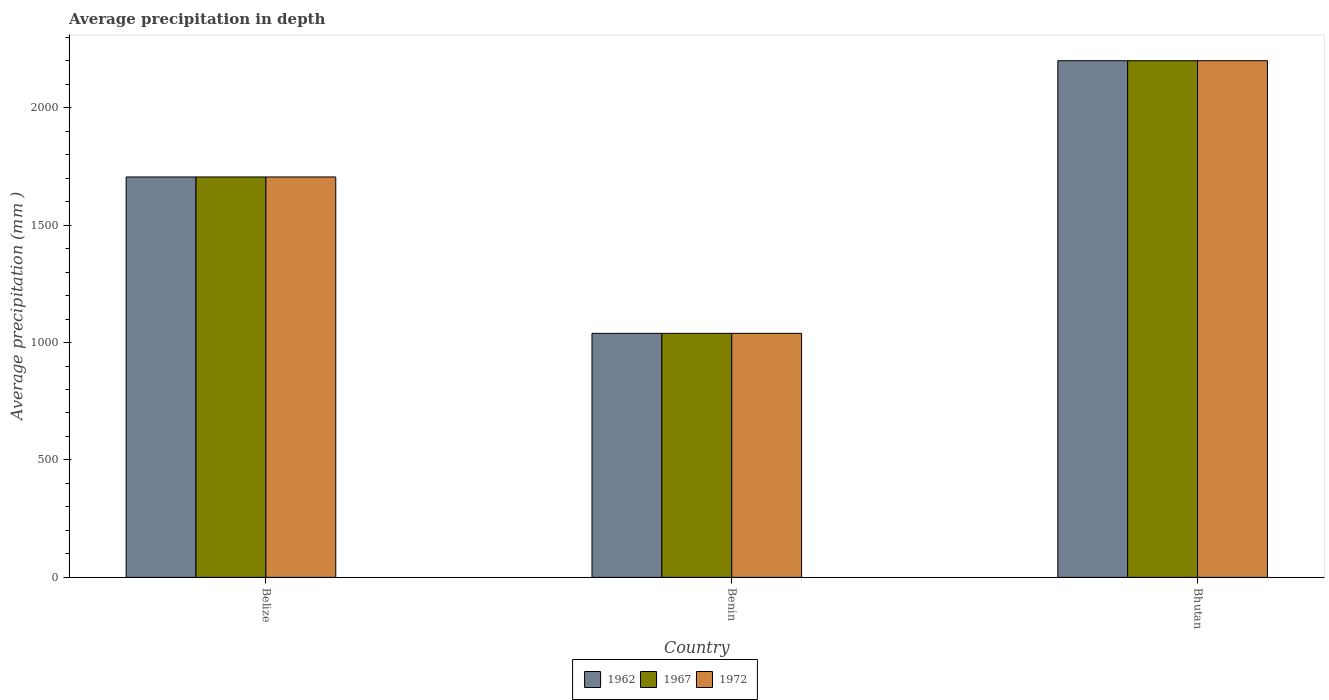Are the number of bars per tick equal to the number of legend labels?
Your answer should be compact. Yes. Are the number of bars on each tick of the X-axis equal?
Give a very brief answer. Yes. How many bars are there on the 2nd tick from the right?
Keep it short and to the point. 3. What is the label of the 3rd group of bars from the left?
Your answer should be very brief. Bhutan. What is the average precipitation in 1972 in Belize?
Offer a very short reply. 1705. Across all countries, what is the maximum average precipitation in 1962?
Ensure brevity in your answer.  2200. Across all countries, what is the minimum average precipitation in 1962?
Provide a short and direct response. 1039. In which country was the average precipitation in 1967 maximum?
Offer a terse response. Bhutan. In which country was the average precipitation in 1962 minimum?
Offer a terse response. Benin. What is the total average precipitation in 1962 in the graph?
Your response must be concise. 4944. What is the difference between the average precipitation in 1962 in Belize and that in Benin?
Ensure brevity in your answer.  666. What is the difference between the average precipitation in 1962 in Benin and the average precipitation in 1967 in Bhutan?
Your answer should be very brief. -1161. What is the average average precipitation in 1967 per country?
Keep it short and to the point. 1648. What is the ratio of the average precipitation in 1962 in Benin to that in Bhutan?
Offer a terse response. 0.47. Is the average precipitation in 1962 in Belize less than that in Bhutan?
Your answer should be compact. Yes. Is the difference between the average precipitation in 1972 in Belize and Bhutan greater than the difference between the average precipitation in 1967 in Belize and Bhutan?
Your answer should be very brief. No. What is the difference between the highest and the second highest average precipitation in 1972?
Ensure brevity in your answer.  495. What is the difference between the highest and the lowest average precipitation in 1962?
Ensure brevity in your answer.  1161. Is the sum of the average precipitation in 1972 in Belize and Bhutan greater than the maximum average precipitation in 1967 across all countries?
Your answer should be compact. Yes. Are all the bars in the graph horizontal?
Provide a succinct answer. No. How many countries are there in the graph?
Give a very brief answer. 3. Does the graph contain any zero values?
Your response must be concise. No. Does the graph contain grids?
Provide a succinct answer. No. How are the legend labels stacked?
Provide a succinct answer. Horizontal. What is the title of the graph?
Give a very brief answer. Average precipitation in depth. Does "1961" appear as one of the legend labels in the graph?
Ensure brevity in your answer.  No. What is the label or title of the X-axis?
Make the answer very short. Country. What is the label or title of the Y-axis?
Provide a short and direct response. Average precipitation (mm ). What is the Average precipitation (mm ) of 1962 in Belize?
Ensure brevity in your answer.  1705. What is the Average precipitation (mm ) in 1967 in Belize?
Offer a very short reply. 1705. What is the Average precipitation (mm ) of 1972 in Belize?
Your answer should be very brief. 1705. What is the Average precipitation (mm ) in 1962 in Benin?
Offer a terse response. 1039. What is the Average precipitation (mm ) of 1967 in Benin?
Make the answer very short. 1039. What is the Average precipitation (mm ) of 1972 in Benin?
Ensure brevity in your answer.  1039. What is the Average precipitation (mm ) of 1962 in Bhutan?
Ensure brevity in your answer.  2200. What is the Average precipitation (mm ) in 1967 in Bhutan?
Your answer should be very brief. 2200. What is the Average precipitation (mm ) of 1972 in Bhutan?
Keep it short and to the point. 2200. Across all countries, what is the maximum Average precipitation (mm ) of 1962?
Offer a very short reply. 2200. Across all countries, what is the maximum Average precipitation (mm ) of 1967?
Your response must be concise. 2200. Across all countries, what is the maximum Average precipitation (mm ) in 1972?
Make the answer very short. 2200. Across all countries, what is the minimum Average precipitation (mm ) in 1962?
Your response must be concise. 1039. Across all countries, what is the minimum Average precipitation (mm ) in 1967?
Make the answer very short. 1039. Across all countries, what is the minimum Average precipitation (mm ) in 1972?
Keep it short and to the point. 1039. What is the total Average precipitation (mm ) of 1962 in the graph?
Give a very brief answer. 4944. What is the total Average precipitation (mm ) of 1967 in the graph?
Your answer should be compact. 4944. What is the total Average precipitation (mm ) in 1972 in the graph?
Your answer should be very brief. 4944. What is the difference between the Average precipitation (mm ) in 1962 in Belize and that in Benin?
Offer a very short reply. 666. What is the difference between the Average precipitation (mm ) in 1967 in Belize and that in Benin?
Offer a terse response. 666. What is the difference between the Average precipitation (mm ) in 1972 in Belize and that in Benin?
Ensure brevity in your answer.  666. What is the difference between the Average precipitation (mm ) in 1962 in Belize and that in Bhutan?
Your answer should be very brief. -495. What is the difference between the Average precipitation (mm ) of 1967 in Belize and that in Bhutan?
Your answer should be compact. -495. What is the difference between the Average precipitation (mm ) in 1972 in Belize and that in Bhutan?
Make the answer very short. -495. What is the difference between the Average precipitation (mm ) of 1962 in Benin and that in Bhutan?
Your answer should be very brief. -1161. What is the difference between the Average precipitation (mm ) of 1967 in Benin and that in Bhutan?
Offer a very short reply. -1161. What is the difference between the Average precipitation (mm ) in 1972 in Benin and that in Bhutan?
Your answer should be very brief. -1161. What is the difference between the Average precipitation (mm ) of 1962 in Belize and the Average precipitation (mm ) of 1967 in Benin?
Your response must be concise. 666. What is the difference between the Average precipitation (mm ) of 1962 in Belize and the Average precipitation (mm ) of 1972 in Benin?
Offer a very short reply. 666. What is the difference between the Average precipitation (mm ) in 1967 in Belize and the Average precipitation (mm ) in 1972 in Benin?
Your answer should be very brief. 666. What is the difference between the Average precipitation (mm ) in 1962 in Belize and the Average precipitation (mm ) in 1967 in Bhutan?
Your answer should be very brief. -495. What is the difference between the Average precipitation (mm ) in 1962 in Belize and the Average precipitation (mm ) in 1972 in Bhutan?
Provide a short and direct response. -495. What is the difference between the Average precipitation (mm ) in 1967 in Belize and the Average precipitation (mm ) in 1972 in Bhutan?
Ensure brevity in your answer.  -495. What is the difference between the Average precipitation (mm ) in 1962 in Benin and the Average precipitation (mm ) in 1967 in Bhutan?
Your answer should be compact. -1161. What is the difference between the Average precipitation (mm ) of 1962 in Benin and the Average precipitation (mm ) of 1972 in Bhutan?
Provide a succinct answer. -1161. What is the difference between the Average precipitation (mm ) of 1967 in Benin and the Average precipitation (mm ) of 1972 in Bhutan?
Provide a succinct answer. -1161. What is the average Average precipitation (mm ) in 1962 per country?
Offer a very short reply. 1648. What is the average Average precipitation (mm ) in 1967 per country?
Offer a very short reply. 1648. What is the average Average precipitation (mm ) of 1972 per country?
Ensure brevity in your answer.  1648. What is the difference between the Average precipitation (mm ) in 1962 and Average precipitation (mm ) in 1967 in Belize?
Ensure brevity in your answer.  0. What is the difference between the Average precipitation (mm ) in 1962 and Average precipitation (mm ) in 1972 in Belize?
Offer a terse response. 0. What is the difference between the Average precipitation (mm ) of 1962 and Average precipitation (mm ) of 1967 in Benin?
Make the answer very short. 0. What is the difference between the Average precipitation (mm ) in 1962 and Average precipitation (mm ) in 1972 in Benin?
Keep it short and to the point. 0. What is the difference between the Average precipitation (mm ) in 1967 and Average precipitation (mm ) in 1972 in Benin?
Keep it short and to the point. 0. What is the difference between the Average precipitation (mm ) of 1962 and Average precipitation (mm ) of 1967 in Bhutan?
Provide a succinct answer. 0. What is the difference between the Average precipitation (mm ) in 1967 and Average precipitation (mm ) in 1972 in Bhutan?
Keep it short and to the point. 0. What is the ratio of the Average precipitation (mm ) of 1962 in Belize to that in Benin?
Your answer should be compact. 1.64. What is the ratio of the Average precipitation (mm ) of 1967 in Belize to that in Benin?
Make the answer very short. 1.64. What is the ratio of the Average precipitation (mm ) in 1972 in Belize to that in Benin?
Ensure brevity in your answer.  1.64. What is the ratio of the Average precipitation (mm ) of 1962 in Belize to that in Bhutan?
Offer a very short reply. 0.78. What is the ratio of the Average precipitation (mm ) of 1967 in Belize to that in Bhutan?
Offer a very short reply. 0.78. What is the ratio of the Average precipitation (mm ) in 1972 in Belize to that in Bhutan?
Your response must be concise. 0.78. What is the ratio of the Average precipitation (mm ) of 1962 in Benin to that in Bhutan?
Your answer should be compact. 0.47. What is the ratio of the Average precipitation (mm ) in 1967 in Benin to that in Bhutan?
Offer a very short reply. 0.47. What is the ratio of the Average precipitation (mm ) in 1972 in Benin to that in Bhutan?
Offer a terse response. 0.47. What is the difference between the highest and the second highest Average precipitation (mm ) in 1962?
Provide a succinct answer. 495. What is the difference between the highest and the second highest Average precipitation (mm ) in 1967?
Offer a terse response. 495. What is the difference between the highest and the second highest Average precipitation (mm ) of 1972?
Make the answer very short. 495. What is the difference between the highest and the lowest Average precipitation (mm ) in 1962?
Make the answer very short. 1161. What is the difference between the highest and the lowest Average precipitation (mm ) in 1967?
Your response must be concise. 1161. What is the difference between the highest and the lowest Average precipitation (mm ) in 1972?
Keep it short and to the point. 1161. 